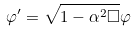<formula> <loc_0><loc_0><loc_500><loc_500>\varphi ^ { \prime } = \sqrt { 1 - \alpha ^ { 2 } \Box } \varphi</formula> 